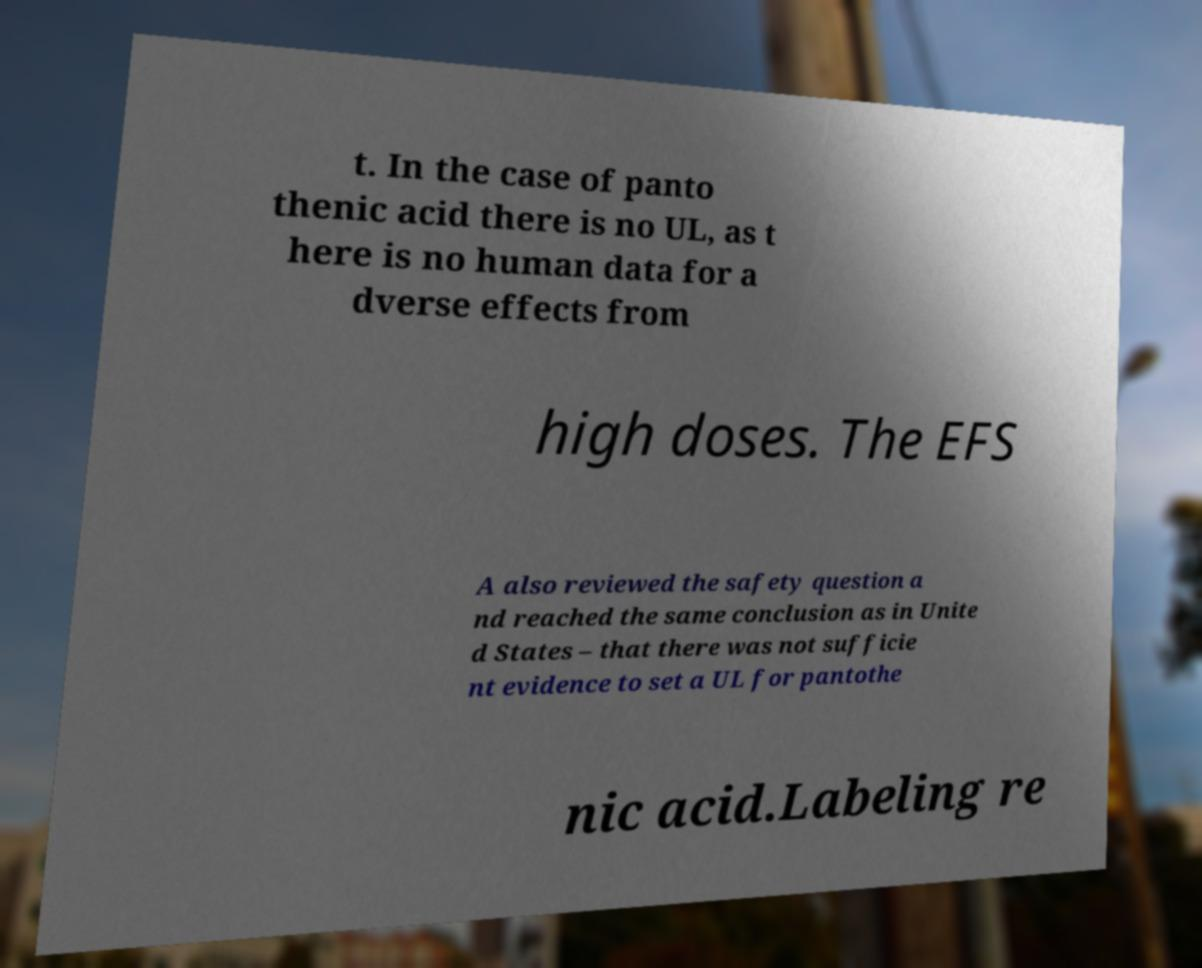Can you accurately transcribe the text from the provided image for me? t. In the case of panto thenic acid there is no UL, as t here is no human data for a dverse effects from high doses. The EFS A also reviewed the safety question a nd reached the same conclusion as in Unite d States – that there was not sufficie nt evidence to set a UL for pantothe nic acid.Labeling re 